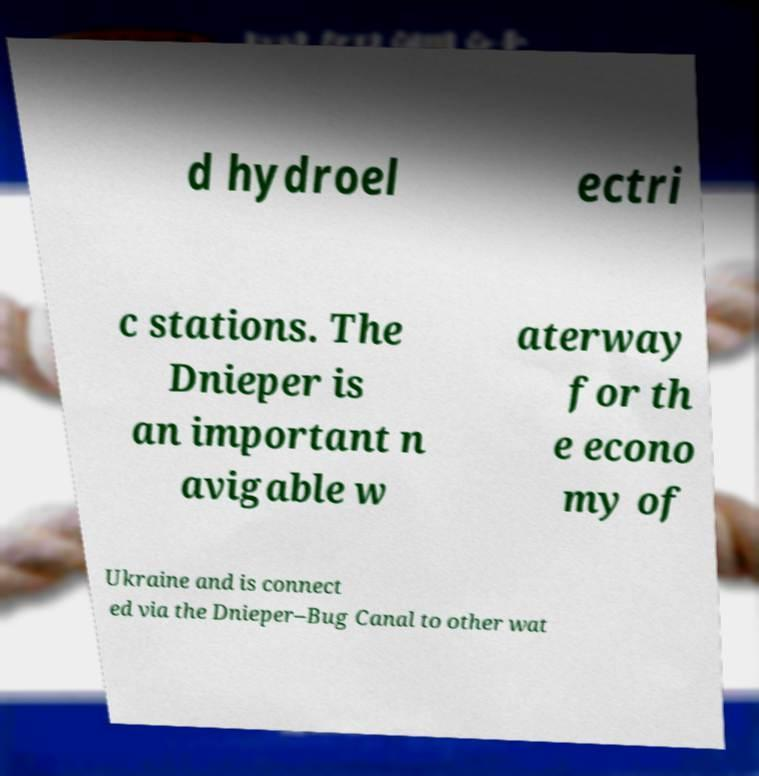Please identify and transcribe the text found in this image. d hydroel ectri c stations. The Dnieper is an important n avigable w aterway for th e econo my of Ukraine and is connect ed via the Dnieper–Bug Canal to other wat 